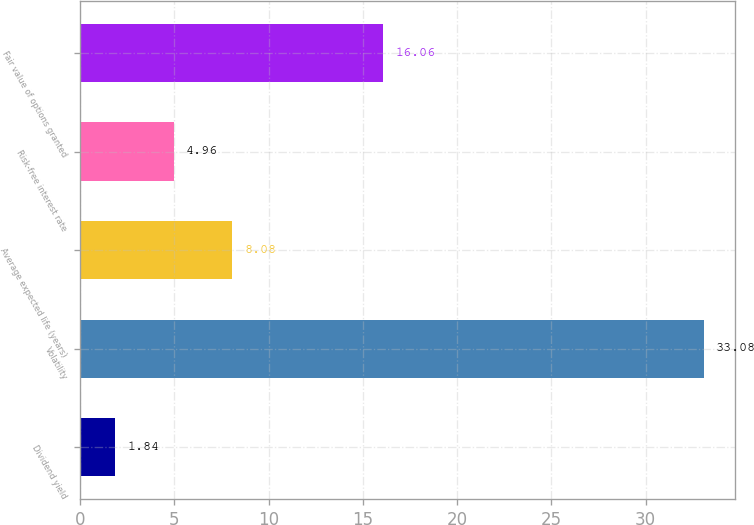Convert chart. <chart><loc_0><loc_0><loc_500><loc_500><bar_chart><fcel>Dividend yield<fcel>Volatility<fcel>Average expected life (years)<fcel>Risk-free interest rate<fcel>Fair value of options granted<nl><fcel>1.84<fcel>33.08<fcel>8.08<fcel>4.96<fcel>16.06<nl></chart> 